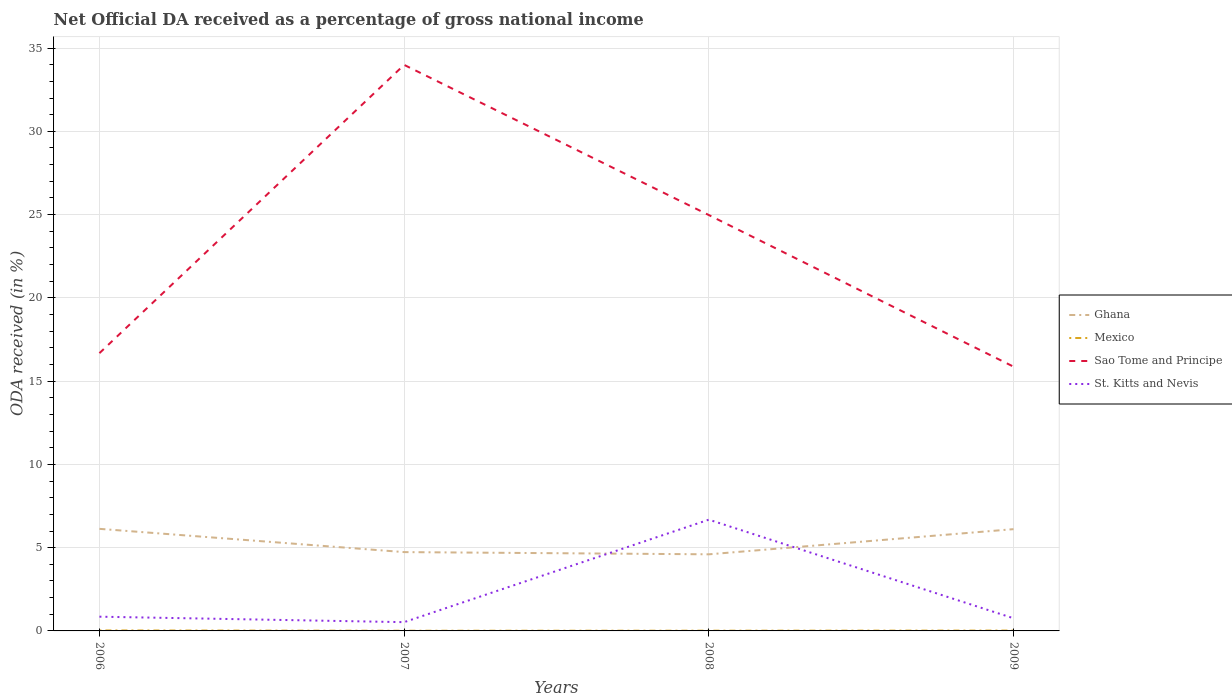Across all years, what is the maximum net official DA received in Ghana?
Make the answer very short. 4.6. In which year was the net official DA received in Sao Tome and Principe maximum?
Keep it short and to the point. 2009. What is the total net official DA received in Ghana in the graph?
Your response must be concise. -1.38. What is the difference between the highest and the second highest net official DA received in Ghana?
Your answer should be very brief. 1.53. What is the difference between the highest and the lowest net official DA received in Ghana?
Your answer should be very brief. 2. Is the net official DA received in Mexico strictly greater than the net official DA received in Sao Tome and Principe over the years?
Your answer should be very brief. Yes. How many lines are there?
Provide a short and direct response. 4. How many years are there in the graph?
Your answer should be compact. 4. What is the difference between two consecutive major ticks on the Y-axis?
Offer a very short reply. 5. Does the graph contain any zero values?
Ensure brevity in your answer.  No. How many legend labels are there?
Offer a very short reply. 4. How are the legend labels stacked?
Your response must be concise. Vertical. What is the title of the graph?
Make the answer very short. Net Official DA received as a percentage of gross national income. Does "Djibouti" appear as one of the legend labels in the graph?
Give a very brief answer. No. What is the label or title of the Y-axis?
Your answer should be compact. ODA received (in %). What is the ODA received (in %) of Ghana in 2006?
Your answer should be compact. 6.13. What is the ODA received (in %) in Mexico in 2006?
Make the answer very short. 0.03. What is the ODA received (in %) in Sao Tome and Principe in 2006?
Your response must be concise. 16.68. What is the ODA received (in %) in St. Kitts and Nevis in 2006?
Offer a terse response. 0.85. What is the ODA received (in %) of Ghana in 2007?
Keep it short and to the point. 4.73. What is the ODA received (in %) in Mexico in 2007?
Give a very brief answer. 0.01. What is the ODA received (in %) in Sao Tome and Principe in 2007?
Ensure brevity in your answer.  33.99. What is the ODA received (in %) of St. Kitts and Nevis in 2007?
Offer a very short reply. 0.53. What is the ODA received (in %) of Ghana in 2008?
Keep it short and to the point. 4.6. What is the ODA received (in %) of Mexico in 2008?
Offer a terse response. 0.01. What is the ODA received (in %) in Sao Tome and Principe in 2008?
Provide a short and direct response. 24.97. What is the ODA received (in %) in St. Kitts and Nevis in 2008?
Ensure brevity in your answer.  6.68. What is the ODA received (in %) of Ghana in 2009?
Offer a very short reply. 6.11. What is the ODA received (in %) in Mexico in 2009?
Provide a succinct answer. 0.02. What is the ODA received (in %) of Sao Tome and Principe in 2009?
Provide a succinct answer. 15.87. What is the ODA received (in %) in St. Kitts and Nevis in 2009?
Offer a very short reply. 0.76. Across all years, what is the maximum ODA received (in %) of Ghana?
Provide a succinct answer. 6.13. Across all years, what is the maximum ODA received (in %) of Mexico?
Your answer should be compact. 0.03. Across all years, what is the maximum ODA received (in %) of Sao Tome and Principe?
Your response must be concise. 33.99. Across all years, what is the maximum ODA received (in %) in St. Kitts and Nevis?
Keep it short and to the point. 6.68. Across all years, what is the minimum ODA received (in %) of Ghana?
Make the answer very short. 4.6. Across all years, what is the minimum ODA received (in %) in Mexico?
Provide a short and direct response. 0.01. Across all years, what is the minimum ODA received (in %) of Sao Tome and Principe?
Keep it short and to the point. 15.87. Across all years, what is the minimum ODA received (in %) in St. Kitts and Nevis?
Provide a succinct answer. 0.53. What is the total ODA received (in %) of Ghana in the graph?
Provide a succinct answer. 21.57. What is the total ODA received (in %) of Mexico in the graph?
Make the answer very short. 0.07. What is the total ODA received (in %) in Sao Tome and Principe in the graph?
Ensure brevity in your answer.  91.51. What is the total ODA received (in %) of St. Kitts and Nevis in the graph?
Offer a terse response. 8.82. What is the difference between the ODA received (in %) of Ghana in 2006 and that in 2007?
Offer a very short reply. 1.4. What is the difference between the ODA received (in %) in Mexico in 2006 and that in 2007?
Offer a terse response. 0.02. What is the difference between the ODA received (in %) in Sao Tome and Principe in 2006 and that in 2007?
Offer a very short reply. -17.31. What is the difference between the ODA received (in %) of St. Kitts and Nevis in 2006 and that in 2007?
Offer a very short reply. 0.33. What is the difference between the ODA received (in %) of Ghana in 2006 and that in 2008?
Provide a succinct answer. 1.53. What is the difference between the ODA received (in %) of Mexico in 2006 and that in 2008?
Ensure brevity in your answer.  0.01. What is the difference between the ODA received (in %) of Sao Tome and Principe in 2006 and that in 2008?
Give a very brief answer. -8.29. What is the difference between the ODA received (in %) of St. Kitts and Nevis in 2006 and that in 2008?
Make the answer very short. -5.83. What is the difference between the ODA received (in %) of Ghana in 2006 and that in 2009?
Your answer should be compact. 0.02. What is the difference between the ODA received (in %) in Mexico in 2006 and that in 2009?
Your answer should be compact. 0.01. What is the difference between the ODA received (in %) in Sao Tome and Principe in 2006 and that in 2009?
Your response must be concise. 0.81. What is the difference between the ODA received (in %) in St. Kitts and Nevis in 2006 and that in 2009?
Keep it short and to the point. 0.09. What is the difference between the ODA received (in %) of Ghana in 2007 and that in 2008?
Offer a terse response. 0.13. What is the difference between the ODA received (in %) in Mexico in 2007 and that in 2008?
Provide a succinct answer. -0. What is the difference between the ODA received (in %) in Sao Tome and Principe in 2007 and that in 2008?
Offer a very short reply. 9.02. What is the difference between the ODA received (in %) of St. Kitts and Nevis in 2007 and that in 2008?
Keep it short and to the point. -6.15. What is the difference between the ODA received (in %) of Ghana in 2007 and that in 2009?
Provide a short and direct response. -1.38. What is the difference between the ODA received (in %) of Mexico in 2007 and that in 2009?
Your answer should be compact. -0.01. What is the difference between the ODA received (in %) of Sao Tome and Principe in 2007 and that in 2009?
Give a very brief answer. 18.12. What is the difference between the ODA received (in %) in St. Kitts and Nevis in 2007 and that in 2009?
Your answer should be very brief. -0.23. What is the difference between the ODA received (in %) of Ghana in 2008 and that in 2009?
Keep it short and to the point. -1.51. What is the difference between the ODA received (in %) in Mexico in 2008 and that in 2009?
Offer a terse response. -0.01. What is the difference between the ODA received (in %) in Sao Tome and Principe in 2008 and that in 2009?
Provide a short and direct response. 9.11. What is the difference between the ODA received (in %) in St. Kitts and Nevis in 2008 and that in 2009?
Offer a very short reply. 5.92. What is the difference between the ODA received (in %) of Ghana in 2006 and the ODA received (in %) of Mexico in 2007?
Give a very brief answer. 6.12. What is the difference between the ODA received (in %) in Ghana in 2006 and the ODA received (in %) in Sao Tome and Principe in 2007?
Your answer should be very brief. -27.86. What is the difference between the ODA received (in %) of Ghana in 2006 and the ODA received (in %) of St. Kitts and Nevis in 2007?
Keep it short and to the point. 5.6. What is the difference between the ODA received (in %) in Mexico in 2006 and the ODA received (in %) in Sao Tome and Principe in 2007?
Provide a succinct answer. -33.96. What is the difference between the ODA received (in %) in Mexico in 2006 and the ODA received (in %) in St. Kitts and Nevis in 2007?
Provide a succinct answer. -0.5. What is the difference between the ODA received (in %) in Sao Tome and Principe in 2006 and the ODA received (in %) in St. Kitts and Nevis in 2007?
Offer a very short reply. 16.15. What is the difference between the ODA received (in %) in Ghana in 2006 and the ODA received (in %) in Mexico in 2008?
Keep it short and to the point. 6.12. What is the difference between the ODA received (in %) of Ghana in 2006 and the ODA received (in %) of Sao Tome and Principe in 2008?
Your answer should be very brief. -18.84. What is the difference between the ODA received (in %) in Ghana in 2006 and the ODA received (in %) in St. Kitts and Nevis in 2008?
Keep it short and to the point. -0.55. What is the difference between the ODA received (in %) in Mexico in 2006 and the ODA received (in %) in Sao Tome and Principe in 2008?
Offer a terse response. -24.94. What is the difference between the ODA received (in %) of Mexico in 2006 and the ODA received (in %) of St. Kitts and Nevis in 2008?
Ensure brevity in your answer.  -6.65. What is the difference between the ODA received (in %) of Sao Tome and Principe in 2006 and the ODA received (in %) of St. Kitts and Nevis in 2008?
Ensure brevity in your answer.  10. What is the difference between the ODA received (in %) in Ghana in 2006 and the ODA received (in %) in Mexico in 2009?
Keep it short and to the point. 6.11. What is the difference between the ODA received (in %) of Ghana in 2006 and the ODA received (in %) of Sao Tome and Principe in 2009?
Your answer should be very brief. -9.74. What is the difference between the ODA received (in %) in Ghana in 2006 and the ODA received (in %) in St. Kitts and Nevis in 2009?
Ensure brevity in your answer.  5.37. What is the difference between the ODA received (in %) of Mexico in 2006 and the ODA received (in %) of Sao Tome and Principe in 2009?
Offer a very short reply. -15.84. What is the difference between the ODA received (in %) of Mexico in 2006 and the ODA received (in %) of St. Kitts and Nevis in 2009?
Offer a terse response. -0.73. What is the difference between the ODA received (in %) of Sao Tome and Principe in 2006 and the ODA received (in %) of St. Kitts and Nevis in 2009?
Make the answer very short. 15.92. What is the difference between the ODA received (in %) of Ghana in 2007 and the ODA received (in %) of Mexico in 2008?
Your answer should be compact. 4.72. What is the difference between the ODA received (in %) of Ghana in 2007 and the ODA received (in %) of Sao Tome and Principe in 2008?
Give a very brief answer. -20.24. What is the difference between the ODA received (in %) in Ghana in 2007 and the ODA received (in %) in St. Kitts and Nevis in 2008?
Your answer should be compact. -1.95. What is the difference between the ODA received (in %) of Mexico in 2007 and the ODA received (in %) of Sao Tome and Principe in 2008?
Give a very brief answer. -24.96. What is the difference between the ODA received (in %) of Mexico in 2007 and the ODA received (in %) of St. Kitts and Nevis in 2008?
Offer a terse response. -6.67. What is the difference between the ODA received (in %) in Sao Tome and Principe in 2007 and the ODA received (in %) in St. Kitts and Nevis in 2008?
Provide a succinct answer. 27.31. What is the difference between the ODA received (in %) of Ghana in 2007 and the ODA received (in %) of Mexico in 2009?
Offer a very short reply. 4.71. What is the difference between the ODA received (in %) in Ghana in 2007 and the ODA received (in %) in Sao Tome and Principe in 2009?
Ensure brevity in your answer.  -11.13. What is the difference between the ODA received (in %) in Ghana in 2007 and the ODA received (in %) in St. Kitts and Nevis in 2009?
Your answer should be compact. 3.97. What is the difference between the ODA received (in %) of Mexico in 2007 and the ODA received (in %) of Sao Tome and Principe in 2009?
Provide a succinct answer. -15.86. What is the difference between the ODA received (in %) in Mexico in 2007 and the ODA received (in %) in St. Kitts and Nevis in 2009?
Your response must be concise. -0.75. What is the difference between the ODA received (in %) in Sao Tome and Principe in 2007 and the ODA received (in %) in St. Kitts and Nevis in 2009?
Provide a succinct answer. 33.23. What is the difference between the ODA received (in %) in Ghana in 2008 and the ODA received (in %) in Mexico in 2009?
Keep it short and to the point. 4.58. What is the difference between the ODA received (in %) of Ghana in 2008 and the ODA received (in %) of Sao Tome and Principe in 2009?
Your response must be concise. -11.27. What is the difference between the ODA received (in %) in Ghana in 2008 and the ODA received (in %) in St. Kitts and Nevis in 2009?
Give a very brief answer. 3.84. What is the difference between the ODA received (in %) of Mexico in 2008 and the ODA received (in %) of Sao Tome and Principe in 2009?
Your response must be concise. -15.85. What is the difference between the ODA received (in %) of Mexico in 2008 and the ODA received (in %) of St. Kitts and Nevis in 2009?
Provide a succinct answer. -0.75. What is the difference between the ODA received (in %) in Sao Tome and Principe in 2008 and the ODA received (in %) in St. Kitts and Nevis in 2009?
Offer a terse response. 24.21. What is the average ODA received (in %) of Ghana per year?
Offer a terse response. 5.39. What is the average ODA received (in %) in Mexico per year?
Provide a succinct answer. 0.02. What is the average ODA received (in %) of Sao Tome and Principe per year?
Your answer should be compact. 22.88. What is the average ODA received (in %) of St. Kitts and Nevis per year?
Make the answer very short. 2.21. In the year 2006, what is the difference between the ODA received (in %) of Ghana and ODA received (in %) of Mexico?
Provide a short and direct response. 6.1. In the year 2006, what is the difference between the ODA received (in %) of Ghana and ODA received (in %) of Sao Tome and Principe?
Your answer should be very brief. -10.55. In the year 2006, what is the difference between the ODA received (in %) in Ghana and ODA received (in %) in St. Kitts and Nevis?
Offer a terse response. 5.28. In the year 2006, what is the difference between the ODA received (in %) in Mexico and ODA received (in %) in Sao Tome and Principe?
Keep it short and to the point. -16.65. In the year 2006, what is the difference between the ODA received (in %) in Mexico and ODA received (in %) in St. Kitts and Nevis?
Keep it short and to the point. -0.83. In the year 2006, what is the difference between the ODA received (in %) in Sao Tome and Principe and ODA received (in %) in St. Kitts and Nevis?
Give a very brief answer. 15.82. In the year 2007, what is the difference between the ODA received (in %) in Ghana and ODA received (in %) in Mexico?
Your response must be concise. 4.72. In the year 2007, what is the difference between the ODA received (in %) of Ghana and ODA received (in %) of Sao Tome and Principe?
Make the answer very short. -29.26. In the year 2007, what is the difference between the ODA received (in %) of Ghana and ODA received (in %) of St. Kitts and Nevis?
Give a very brief answer. 4.21. In the year 2007, what is the difference between the ODA received (in %) in Mexico and ODA received (in %) in Sao Tome and Principe?
Keep it short and to the point. -33.98. In the year 2007, what is the difference between the ODA received (in %) of Mexico and ODA received (in %) of St. Kitts and Nevis?
Provide a short and direct response. -0.52. In the year 2007, what is the difference between the ODA received (in %) in Sao Tome and Principe and ODA received (in %) in St. Kitts and Nevis?
Ensure brevity in your answer.  33.46. In the year 2008, what is the difference between the ODA received (in %) of Ghana and ODA received (in %) of Mexico?
Offer a very short reply. 4.59. In the year 2008, what is the difference between the ODA received (in %) in Ghana and ODA received (in %) in Sao Tome and Principe?
Ensure brevity in your answer.  -20.37. In the year 2008, what is the difference between the ODA received (in %) in Ghana and ODA received (in %) in St. Kitts and Nevis?
Ensure brevity in your answer.  -2.08. In the year 2008, what is the difference between the ODA received (in %) in Mexico and ODA received (in %) in Sao Tome and Principe?
Provide a succinct answer. -24.96. In the year 2008, what is the difference between the ODA received (in %) of Mexico and ODA received (in %) of St. Kitts and Nevis?
Offer a very short reply. -6.67. In the year 2008, what is the difference between the ODA received (in %) in Sao Tome and Principe and ODA received (in %) in St. Kitts and Nevis?
Offer a terse response. 18.29. In the year 2009, what is the difference between the ODA received (in %) in Ghana and ODA received (in %) in Mexico?
Offer a terse response. 6.09. In the year 2009, what is the difference between the ODA received (in %) of Ghana and ODA received (in %) of Sao Tome and Principe?
Your answer should be very brief. -9.76. In the year 2009, what is the difference between the ODA received (in %) of Ghana and ODA received (in %) of St. Kitts and Nevis?
Your answer should be compact. 5.35. In the year 2009, what is the difference between the ODA received (in %) of Mexico and ODA received (in %) of Sao Tome and Principe?
Offer a very short reply. -15.85. In the year 2009, what is the difference between the ODA received (in %) in Mexico and ODA received (in %) in St. Kitts and Nevis?
Provide a succinct answer. -0.74. In the year 2009, what is the difference between the ODA received (in %) in Sao Tome and Principe and ODA received (in %) in St. Kitts and Nevis?
Provide a succinct answer. 15.11. What is the ratio of the ODA received (in %) of Ghana in 2006 to that in 2007?
Offer a very short reply. 1.3. What is the ratio of the ODA received (in %) in Mexico in 2006 to that in 2007?
Give a very brief answer. 2.57. What is the ratio of the ODA received (in %) in Sao Tome and Principe in 2006 to that in 2007?
Give a very brief answer. 0.49. What is the ratio of the ODA received (in %) in St. Kitts and Nevis in 2006 to that in 2007?
Give a very brief answer. 1.62. What is the ratio of the ODA received (in %) in Ghana in 2006 to that in 2008?
Ensure brevity in your answer.  1.33. What is the ratio of the ODA received (in %) in Mexico in 2006 to that in 2008?
Offer a terse response. 2.07. What is the ratio of the ODA received (in %) in Sao Tome and Principe in 2006 to that in 2008?
Your answer should be compact. 0.67. What is the ratio of the ODA received (in %) in St. Kitts and Nevis in 2006 to that in 2008?
Keep it short and to the point. 0.13. What is the ratio of the ODA received (in %) in Ghana in 2006 to that in 2009?
Offer a very short reply. 1. What is the ratio of the ODA received (in %) of Mexico in 2006 to that in 2009?
Give a very brief answer. 1.36. What is the ratio of the ODA received (in %) in Sao Tome and Principe in 2006 to that in 2009?
Offer a terse response. 1.05. What is the ratio of the ODA received (in %) in St. Kitts and Nevis in 2006 to that in 2009?
Provide a short and direct response. 1.12. What is the ratio of the ODA received (in %) in Ghana in 2007 to that in 2008?
Ensure brevity in your answer.  1.03. What is the ratio of the ODA received (in %) in Mexico in 2007 to that in 2008?
Your response must be concise. 0.81. What is the ratio of the ODA received (in %) of Sao Tome and Principe in 2007 to that in 2008?
Your answer should be very brief. 1.36. What is the ratio of the ODA received (in %) of St. Kitts and Nevis in 2007 to that in 2008?
Your answer should be very brief. 0.08. What is the ratio of the ODA received (in %) in Ghana in 2007 to that in 2009?
Keep it short and to the point. 0.77. What is the ratio of the ODA received (in %) of Mexico in 2007 to that in 2009?
Your answer should be very brief. 0.53. What is the ratio of the ODA received (in %) of Sao Tome and Principe in 2007 to that in 2009?
Offer a very short reply. 2.14. What is the ratio of the ODA received (in %) of St. Kitts and Nevis in 2007 to that in 2009?
Make the answer very short. 0.69. What is the ratio of the ODA received (in %) of Ghana in 2008 to that in 2009?
Provide a succinct answer. 0.75. What is the ratio of the ODA received (in %) in Mexico in 2008 to that in 2009?
Make the answer very short. 0.66. What is the ratio of the ODA received (in %) in Sao Tome and Principe in 2008 to that in 2009?
Your answer should be very brief. 1.57. What is the ratio of the ODA received (in %) in St. Kitts and Nevis in 2008 to that in 2009?
Offer a very short reply. 8.79. What is the difference between the highest and the second highest ODA received (in %) of Ghana?
Your answer should be very brief. 0.02. What is the difference between the highest and the second highest ODA received (in %) in Mexico?
Give a very brief answer. 0.01. What is the difference between the highest and the second highest ODA received (in %) in Sao Tome and Principe?
Offer a very short reply. 9.02. What is the difference between the highest and the second highest ODA received (in %) of St. Kitts and Nevis?
Your answer should be compact. 5.83. What is the difference between the highest and the lowest ODA received (in %) in Ghana?
Your answer should be very brief. 1.53. What is the difference between the highest and the lowest ODA received (in %) in Mexico?
Provide a short and direct response. 0.02. What is the difference between the highest and the lowest ODA received (in %) in Sao Tome and Principe?
Keep it short and to the point. 18.12. What is the difference between the highest and the lowest ODA received (in %) in St. Kitts and Nevis?
Offer a very short reply. 6.15. 